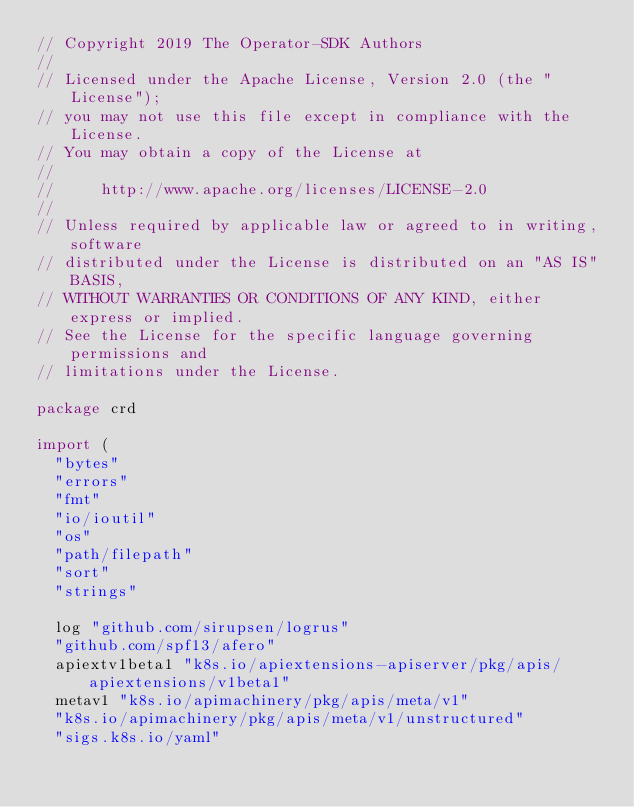<code> <loc_0><loc_0><loc_500><loc_500><_Go_>// Copyright 2019 The Operator-SDK Authors
//
// Licensed under the Apache License, Version 2.0 (the "License");
// you may not use this file except in compliance with the License.
// You may obtain a copy of the License at
//
//     http://www.apache.org/licenses/LICENSE-2.0
//
// Unless required by applicable law or agreed to in writing, software
// distributed under the License is distributed on an "AS IS" BASIS,
// WITHOUT WARRANTIES OR CONDITIONS OF ANY KIND, either express or implied.
// See the License for the specific language governing permissions and
// limitations under the License.

package crd

import (
	"bytes"
	"errors"
	"fmt"
	"io/ioutil"
	"os"
	"path/filepath"
	"sort"
	"strings"

	log "github.com/sirupsen/logrus"
	"github.com/spf13/afero"
	apiextv1beta1 "k8s.io/apiextensions-apiserver/pkg/apis/apiextensions/v1beta1"
	metav1 "k8s.io/apimachinery/pkg/apis/meta/v1"
	"k8s.io/apimachinery/pkg/apis/meta/v1/unstructured"
	"sigs.k8s.io/yaml"
</code> 